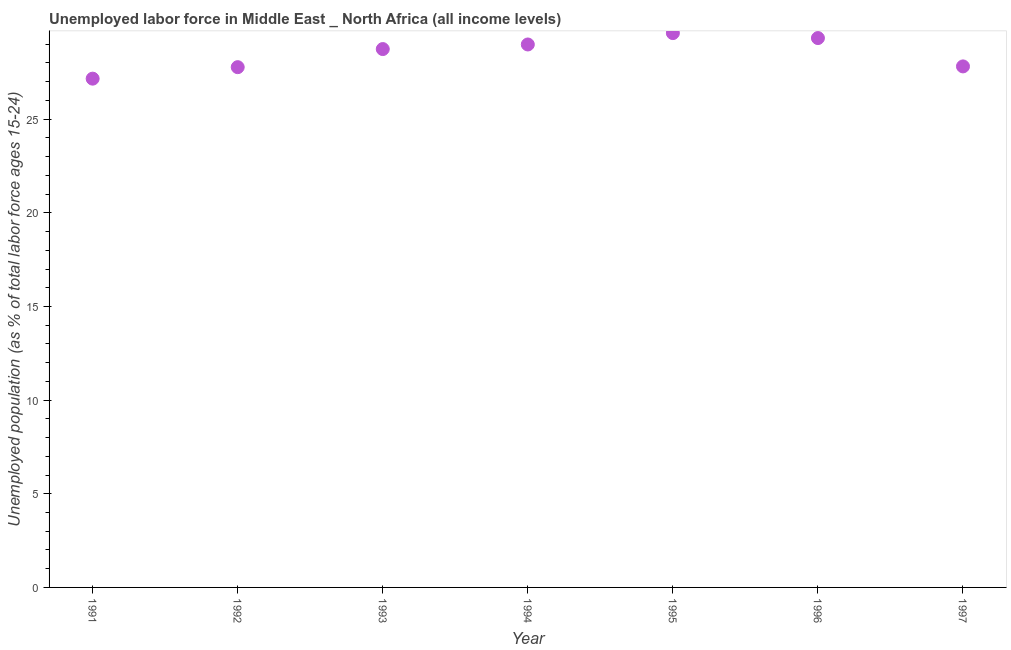What is the total unemployed youth population in 1993?
Provide a short and direct response. 28.74. Across all years, what is the maximum total unemployed youth population?
Your response must be concise. 29.6. Across all years, what is the minimum total unemployed youth population?
Provide a short and direct response. 27.16. In which year was the total unemployed youth population maximum?
Provide a succinct answer. 1995. What is the sum of the total unemployed youth population?
Your answer should be very brief. 199.42. What is the difference between the total unemployed youth population in 1991 and 1992?
Ensure brevity in your answer.  -0.61. What is the average total unemployed youth population per year?
Offer a terse response. 28.49. What is the median total unemployed youth population?
Your answer should be compact. 28.74. In how many years, is the total unemployed youth population greater than 12 %?
Offer a terse response. 7. What is the ratio of the total unemployed youth population in 1995 to that in 1996?
Offer a terse response. 1.01. Is the total unemployed youth population in 1993 less than that in 1995?
Keep it short and to the point. Yes. Is the difference between the total unemployed youth population in 1996 and 1997 greater than the difference between any two years?
Provide a short and direct response. No. What is the difference between the highest and the second highest total unemployed youth population?
Provide a succinct answer. 0.26. What is the difference between the highest and the lowest total unemployed youth population?
Provide a short and direct response. 2.43. Does the total unemployed youth population monotonically increase over the years?
Your response must be concise. No. How many dotlines are there?
Provide a short and direct response. 1. What is the title of the graph?
Provide a short and direct response. Unemployed labor force in Middle East _ North Africa (all income levels). What is the label or title of the Y-axis?
Make the answer very short. Unemployed population (as % of total labor force ages 15-24). What is the Unemployed population (as % of total labor force ages 15-24) in 1991?
Make the answer very short. 27.16. What is the Unemployed population (as % of total labor force ages 15-24) in 1992?
Your answer should be very brief. 27.78. What is the Unemployed population (as % of total labor force ages 15-24) in 1993?
Offer a very short reply. 28.74. What is the Unemployed population (as % of total labor force ages 15-24) in 1994?
Your answer should be compact. 28.99. What is the Unemployed population (as % of total labor force ages 15-24) in 1995?
Provide a succinct answer. 29.6. What is the Unemployed population (as % of total labor force ages 15-24) in 1996?
Give a very brief answer. 29.33. What is the Unemployed population (as % of total labor force ages 15-24) in 1997?
Your response must be concise. 27.82. What is the difference between the Unemployed population (as % of total labor force ages 15-24) in 1991 and 1992?
Ensure brevity in your answer.  -0.61. What is the difference between the Unemployed population (as % of total labor force ages 15-24) in 1991 and 1993?
Your answer should be very brief. -1.58. What is the difference between the Unemployed population (as % of total labor force ages 15-24) in 1991 and 1994?
Provide a short and direct response. -1.82. What is the difference between the Unemployed population (as % of total labor force ages 15-24) in 1991 and 1995?
Offer a terse response. -2.43. What is the difference between the Unemployed population (as % of total labor force ages 15-24) in 1991 and 1996?
Provide a succinct answer. -2.17. What is the difference between the Unemployed population (as % of total labor force ages 15-24) in 1991 and 1997?
Keep it short and to the point. -0.65. What is the difference between the Unemployed population (as % of total labor force ages 15-24) in 1992 and 1993?
Offer a terse response. -0.97. What is the difference between the Unemployed population (as % of total labor force ages 15-24) in 1992 and 1994?
Offer a terse response. -1.21. What is the difference between the Unemployed population (as % of total labor force ages 15-24) in 1992 and 1995?
Your answer should be compact. -1.82. What is the difference between the Unemployed population (as % of total labor force ages 15-24) in 1992 and 1996?
Provide a succinct answer. -1.55. What is the difference between the Unemployed population (as % of total labor force ages 15-24) in 1992 and 1997?
Make the answer very short. -0.04. What is the difference between the Unemployed population (as % of total labor force ages 15-24) in 1993 and 1994?
Ensure brevity in your answer.  -0.25. What is the difference between the Unemployed population (as % of total labor force ages 15-24) in 1993 and 1995?
Provide a short and direct response. -0.85. What is the difference between the Unemployed population (as % of total labor force ages 15-24) in 1993 and 1996?
Your answer should be compact. -0.59. What is the difference between the Unemployed population (as % of total labor force ages 15-24) in 1993 and 1997?
Ensure brevity in your answer.  0.93. What is the difference between the Unemployed population (as % of total labor force ages 15-24) in 1994 and 1995?
Your answer should be very brief. -0.61. What is the difference between the Unemployed population (as % of total labor force ages 15-24) in 1994 and 1996?
Keep it short and to the point. -0.34. What is the difference between the Unemployed population (as % of total labor force ages 15-24) in 1994 and 1997?
Ensure brevity in your answer.  1.17. What is the difference between the Unemployed population (as % of total labor force ages 15-24) in 1995 and 1996?
Give a very brief answer. 0.26. What is the difference between the Unemployed population (as % of total labor force ages 15-24) in 1995 and 1997?
Ensure brevity in your answer.  1.78. What is the difference between the Unemployed population (as % of total labor force ages 15-24) in 1996 and 1997?
Provide a succinct answer. 1.51. What is the ratio of the Unemployed population (as % of total labor force ages 15-24) in 1991 to that in 1993?
Offer a very short reply. 0.94. What is the ratio of the Unemployed population (as % of total labor force ages 15-24) in 1991 to that in 1994?
Make the answer very short. 0.94. What is the ratio of the Unemployed population (as % of total labor force ages 15-24) in 1991 to that in 1995?
Your answer should be very brief. 0.92. What is the ratio of the Unemployed population (as % of total labor force ages 15-24) in 1991 to that in 1996?
Your answer should be compact. 0.93. What is the ratio of the Unemployed population (as % of total labor force ages 15-24) in 1992 to that in 1994?
Give a very brief answer. 0.96. What is the ratio of the Unemployed population (as % of total labor force ages 15-24) in 1992 to that in 1995?
Provide a short and direct response. 0.94. What is the ratio of the Unemployed population (as % of total labor force ages 15-24) in 1992 to that in 1996?
Offer a terse response. 0.95. What is the ratio of the Unemployed population (as % of total labor force ages 15-24) in 1992 to that in 1997?
Keep it short and to the point. 1. What is the ratio of the Unemployed population (as % of total labor force ages 15-24) in 1993 to that in 1994?
Give a very brief answer. 0.99. What is the ratio of the Unemployed population (as % of total labor force ages 15-24) in 1993 to that in 1995?
Your answer should be very brief. 0.97. What is the ratio of the Unemployed population (as % of total labor force ages 15-24) in 1993 to that in 1997?
Your answer should be very brief. 1.03. What is the ratio of the Unemployed population (as % of total labor force ages 15-24) in 1994 to that in 1997?
Provide a short and direct response. 1.04. What is the ratio of the Unemployed population (as % of total labor force ages 15-24) in 1995 to that in 1996?
Offer a terse response. 1.01. What is the ratio of the Unemployed population (as % of total labor force ages 15-24) in 1995 to that in 1997?
Your response must be concise. 1.06. What is the ratio of the Unemployed population (as % of total labor force ages 15-24) in 1996 to that in 1997?
Offer a terse response. 1.05. 